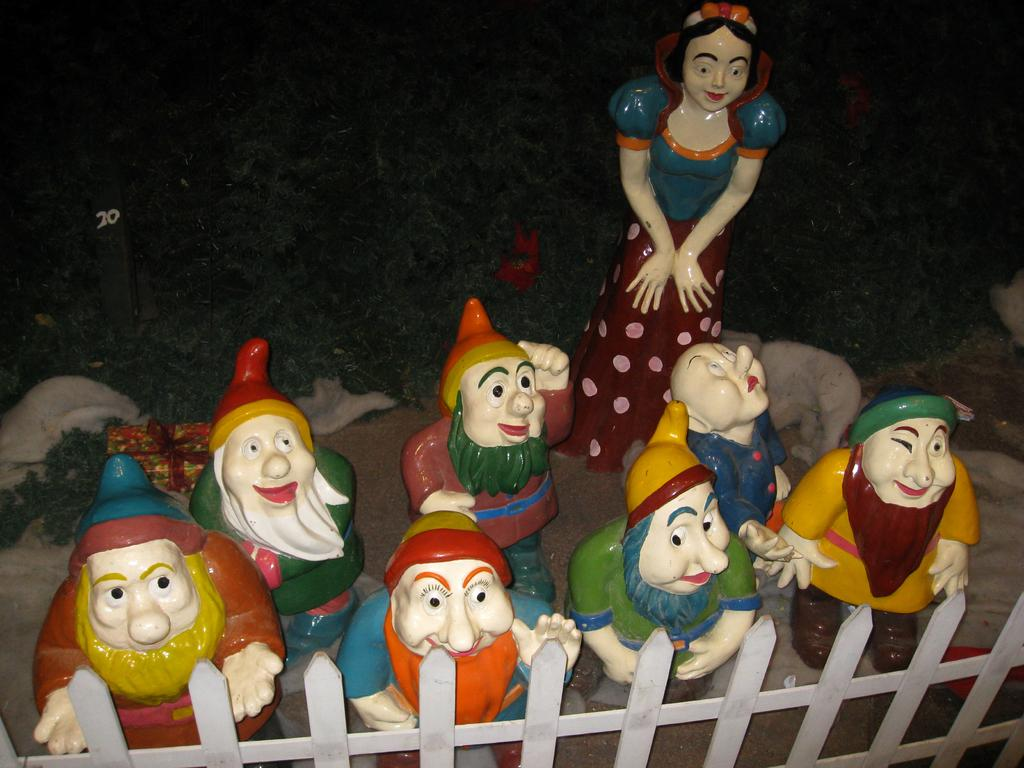What can be seen in the foreground of the image? There are toys and railing in the foreground of the image. What is located in the background of the image? There is a gift box and trees in the background of the image. What type of observation can be made about the clouds in the image? There are no clouds present in the image, so no observation about clouds can be made. What is the rail's purpose in the image? The railing in the image is likely for safety or to prevent falls, but its specific purpose cannot be determined without additional context. 